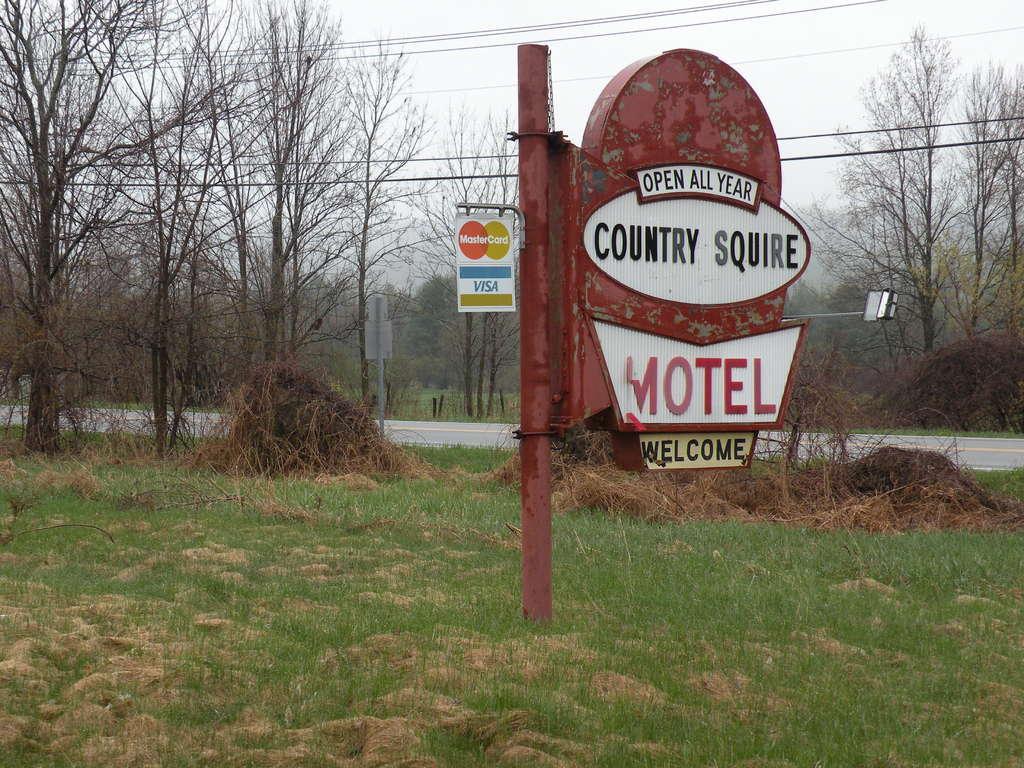Describe this image in one or two sentences. In the image there is a welcome board dug in the ground and behind that there are many trees. 